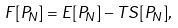<formula> <loc_0><loc_0><loc_500><loc_500>F [ P _ { N } ] = E [ P _ { N } ] - T S [ P _ { N } ] ,</formula> 